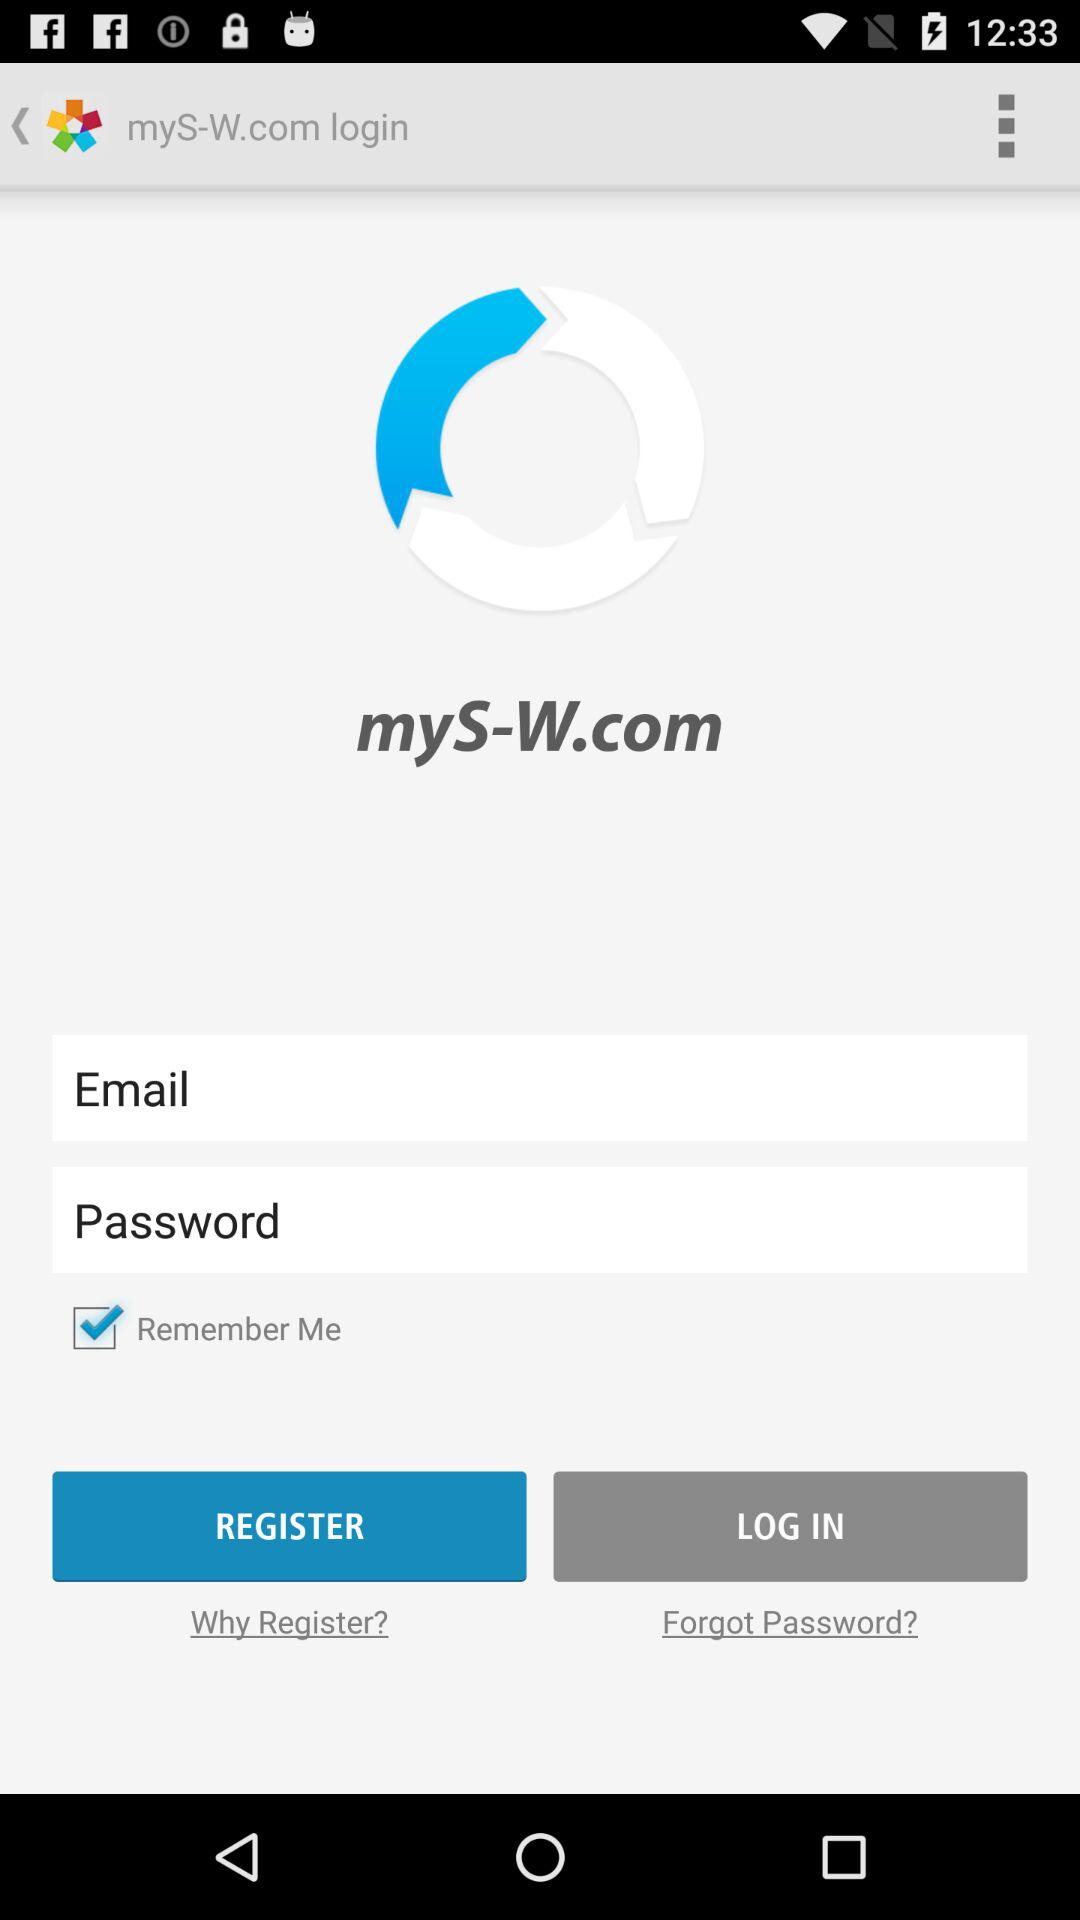What is the name of the application? The name of the application is "myS-W.com". 